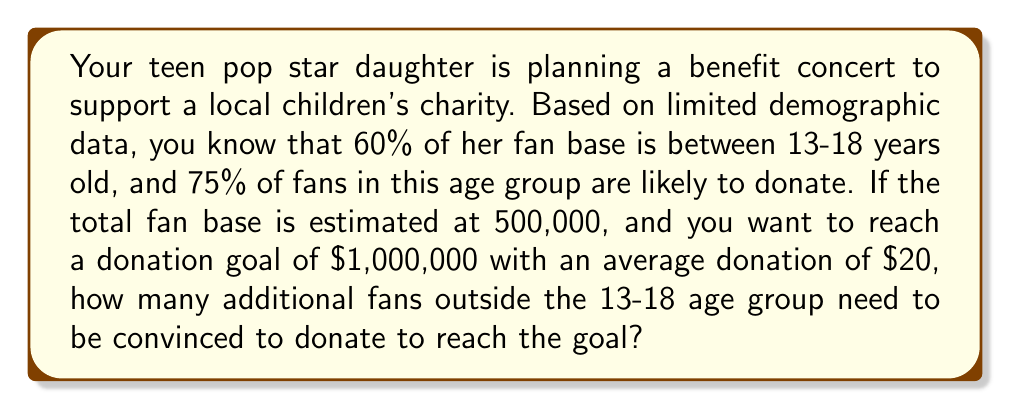Teach me how to tackle this problem. Let's break this down step-by-step:

1) First, calculate the number of fans in the 13-18 age group:
   $500,000 \times 60\% = 300,000$ fans

2) Calculate the number of fans in this age group likely to donate:
   $300,000 \times 75\% = 225,000$ fans

3) Calculate the total amount these fans are likely to donate:
   $225,000 \times \$20 = \$4,500,000$

4) This exceeds the $1,000,000 goal, so no additional fans are needed.

5) To find how many fans are actually needed to reach the goal:
   Let $x$ be the number of fans needed
   $$x \times \$20 = \$1,000,000$$
   $$x = \frac{\$1,000,000}{\$20} = 50,000\text{ fans}$$

6) Since we have 225,000 fans likely to donate, we have more than enough to reach the goal.

7) The excess number of fans:
   $225,000 - 50,000 = 175,000$ fans

Therefore, no additional fans outside the 13-18 age group need to be convinced to donate. In fact, the goal can be reached with just a portion of the 13-18 age group fans who are likely to donate.
Answer: 0 additional fans 